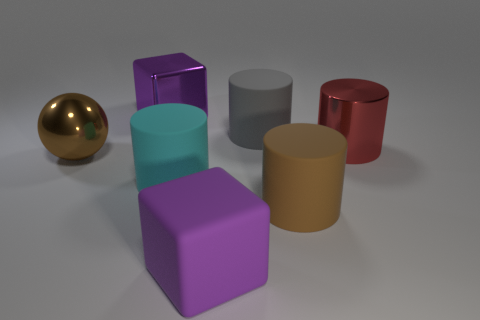Subtract all red cylinders. How many cylinders are left? 3 Subtract all red cylinders. How many cylinders are left? 3 Subtract all spheres. How many objects are left? 6 Add 2 gray rubber cylinders. How many objects exist? 9 Subtract 2 cubes. How many cubes are left? 0 Subtract all gray blocks. How many cyan cylinders are left? 1 Add 5 tiny brown rubber cylinders. How many tiny brown rubber cylinders exist? 5 Subtract 1 gray cylinders. How many objects are left? 6 Subtract all cyan blocks. Subtract all green spheres. How many blocks are left? 2 Subtract all small matte spheres. Subtract all large cyan matte cylinders. How many objects are left? 6 